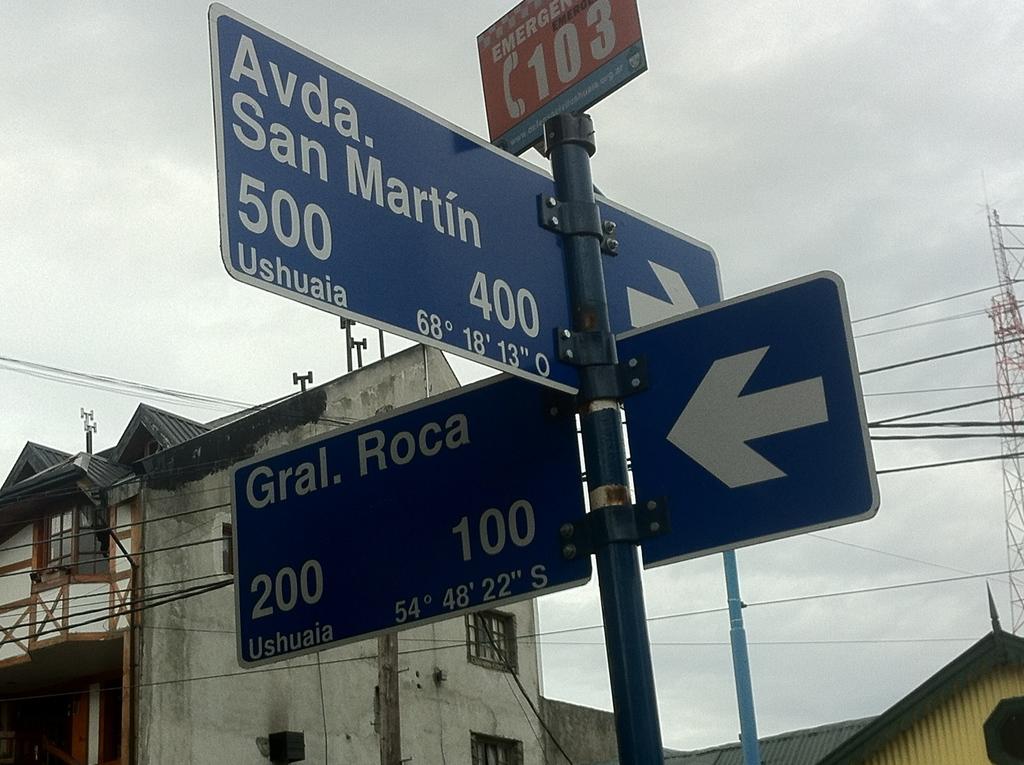What number can one call in case of emergency?
Give a very brief answer. 103. 